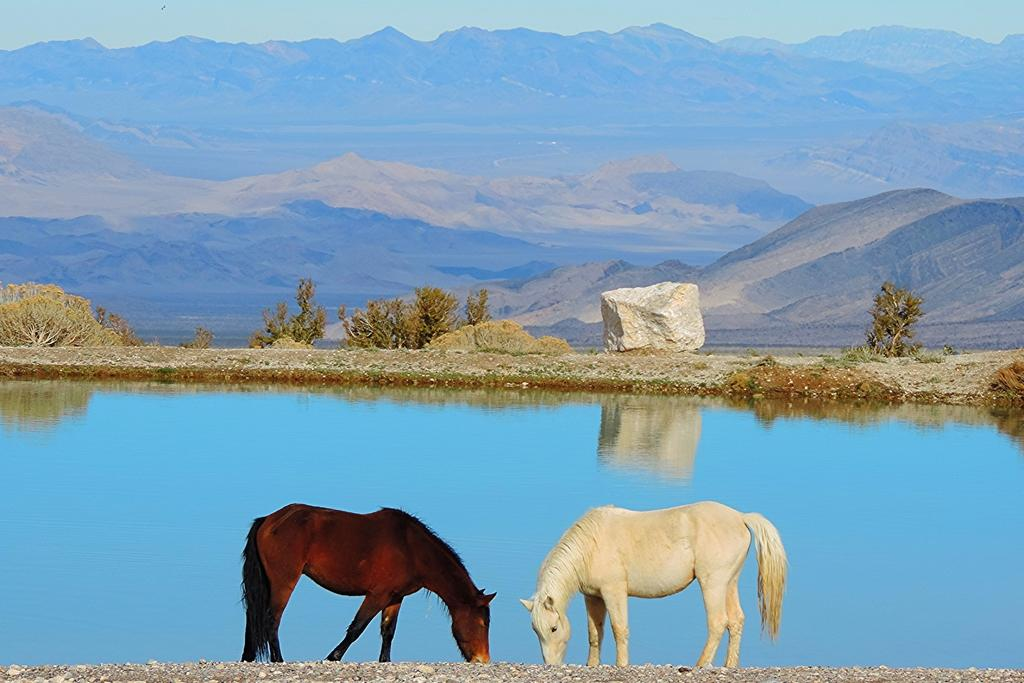What is present in the image that represents a natural body of water? There is water in the image. How many horses are in the image, and what are their colors? There are two horses in the image, one is white, and the other is brown. What type of geological formation can be seen in the image? There is a rock in the image. What type of vegetation is present in the image? There are trees in the image. What type of landscape feature can be seen in the image? There are hills in the image. What part of the natural environment is visible in the image? The sky is visible in the image. What is the tendency of the hour to change in the image? There is no reference to time or hours in the image, so it is not possible to determine any tendency related to hours. What type of spot can be seen on the white horse in the image? There is no mention of any spots on the horses in the image, so it is not possible to describe any spots. 